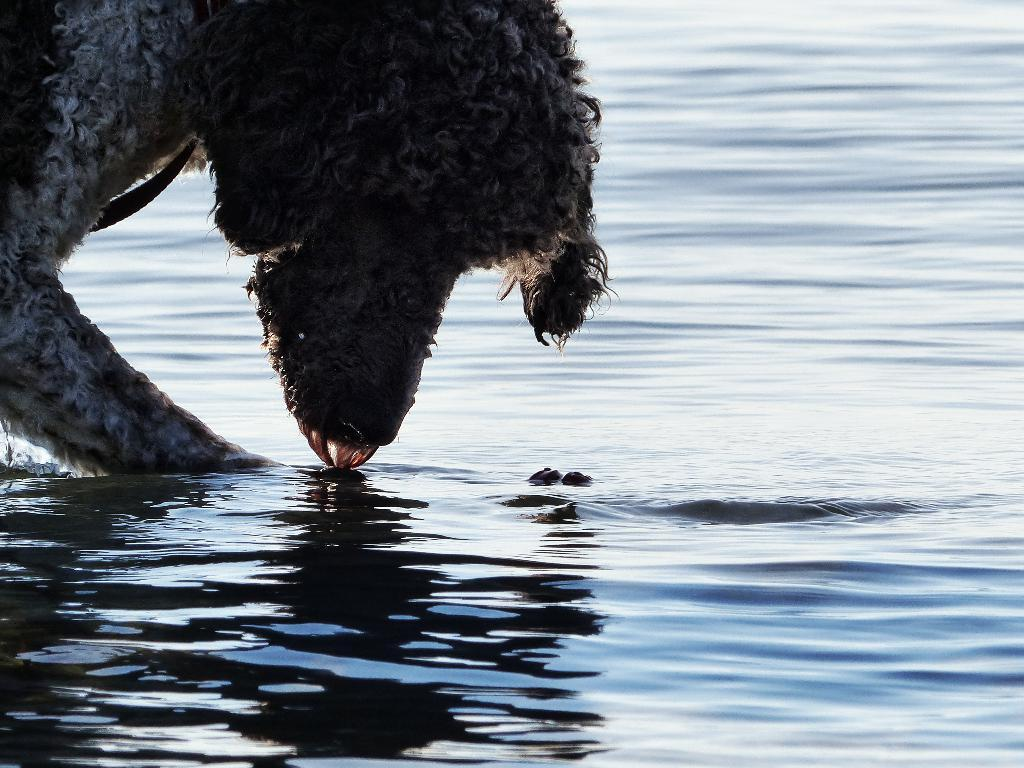What animal can be seen in the image? There is a dog in the image. What is the dog doing in the image? The dog is drinking water. Can you describe the liquid that the dog is consuming? There is water visible in the image. What type of plants can be seen growing in the water in the image? There are no plants visible in the image, and the dog is drinking water, not a plant-based liquid. 